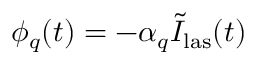Convert formula to latex. <formula><loc_0><loc_0><loc_500><loc_500>\phi _ { q } ( t ) = - \alpha _ { q } \tilde { I } _ { l a s } ( t )</formula> 